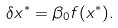Convert formula to latex. <formula><loc_0><loc_0><loc_500><loc_500>\delta x ^ { * } = \beta _ { 0 } f ( x ^ { * } ) .</formula> 